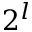<formula> <loc_0><loc_0><loc_500><loc_500>2 ^ { l }</formula> 